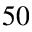Convert formula to latex. <formula><loc_0><loc_0><loc_500><loc_500>5 0</formula> 